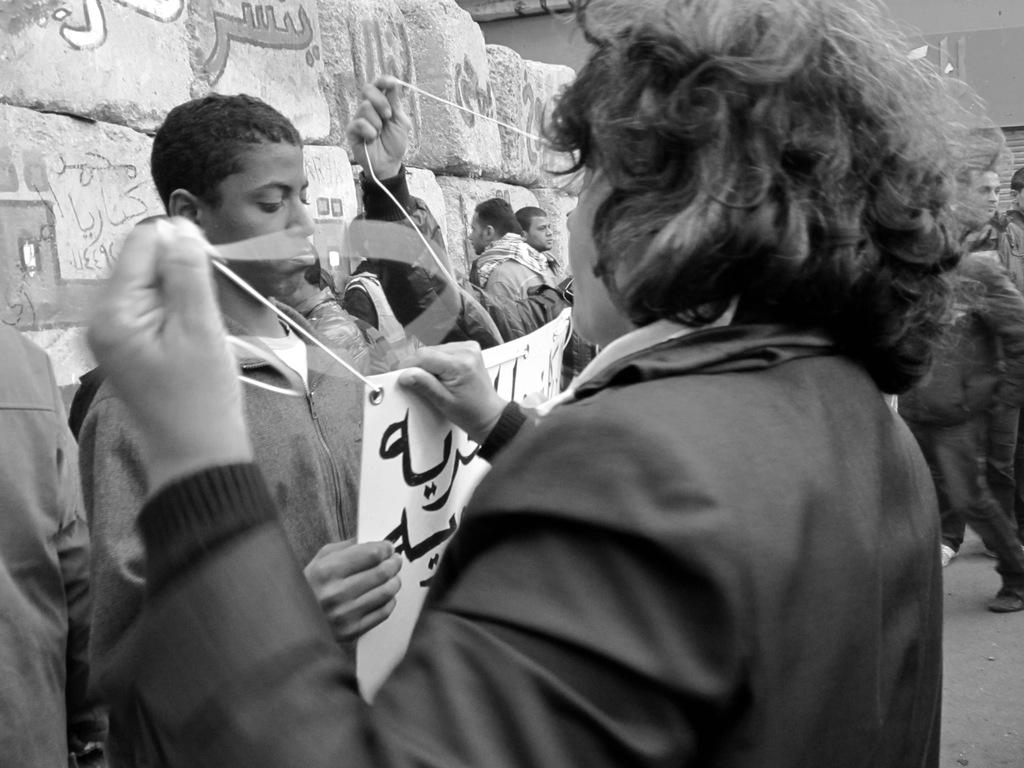What are the people in the image doing near the wall? The people in the image are standing near a wall. What are some of the people holding in the image? Some people are holding boards in the image. What type of office can be seen in the image? There is no office present in the image; it features people standing near a wall and holding boards. Who is leading the group of people in the image? There is no indication of a leader or group in the image; it only shows people standing near a wall and holding boards. 